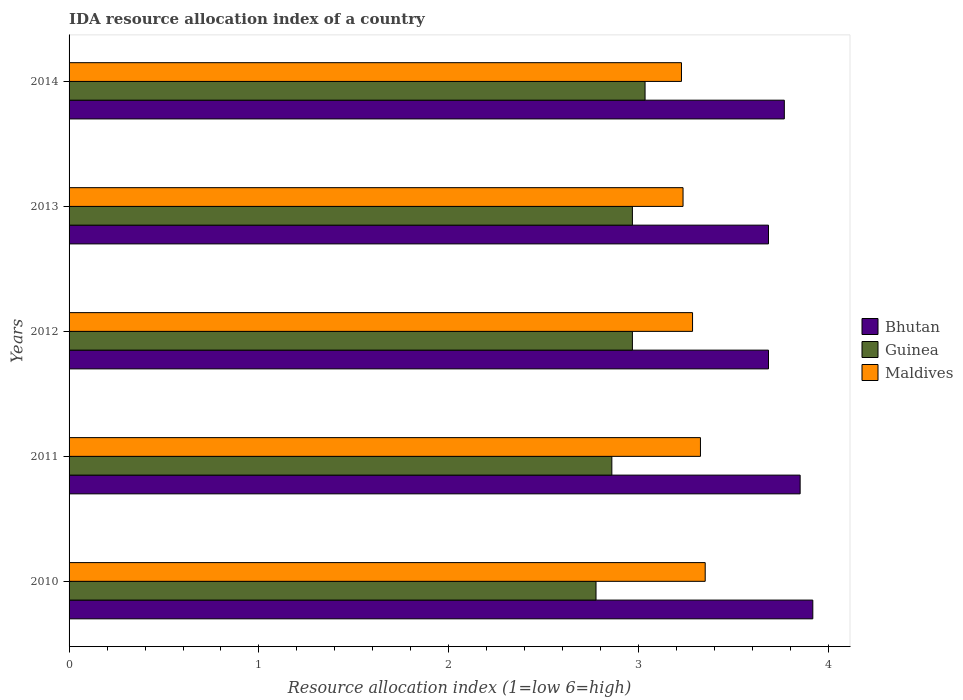Are the number of bars per tick equal to the number of legend labels?
Keep it short and to the point. Yes. Are the number of bars on each tick of the Y-axis equal?
Your answer should be compact. Yes. How many bars are there on the 1st tick from the bottom?
Give a very brief answer. 3. In how many cases, is the number of bars for a given year not equal to the number of legend labels?
Provide a short and direct response. 0. What is the IDA resource allocation index in Maldives in 2012?
Offer a terse response. 3.28. Across all years, what is the maximum IDA resource allocation index in Guinea?
Provide a succinct answer. 3.03. Across all years, what is the minimum IDA resource allocation index in Bhutan?
Keep it short and to the point. 3.68. In which year was the IDA resource allocation index in Guinea minimum?
Offer a very short reply. 2010. What is the total IDA resource allocation index in Maldives in the graph?
Provide a succinct answer. 16.42. What is the difference between the IDA resource allocation index in Bhutan in 2013 and that in 2014?
Your response must be concise. -0.08. What is the difference between the IDA resource allocation index in Guinea in 2010 and the IDA resource allocation index in Maldives in 2014?
Your answer should be very brief. -0.45. What is the average IDA resource allocation index in Guinea per year?
Offer a terse response. 2.92. In the year 2013, what is the difference between the IDA resource allocation index in Bhutan and IDA resource allocation index in Guinea?
Ensure brevity in your answer.  0.72. What is the ratio of the IDA resource allocation index in Maldives in 2010 to that in 2012?
Your response must be concise. 1.02. Is the IDA resource allocation index in Bhutan in 2010 less than that in 2013?
Keep it short and to the point. No. What is the difference between the highest and the second highest IDA resource allocation index in Maldives?
Give a very brief answer. 0.02. What is the difference between the highest and the lowest IDA resource allocation index in Bhutan?
Your answer should be very brief. 0.23. What does the 2nd bar from the top in 2014 represents?
Provide a succinct answer. Guinea. What does the 3rd bar from the bottom in 2011 represents?
Offer a very short reply. Maldives. Are all the bars in the graph horizontal?
Offer a very short reply. Yes. How many years are there in the graph?
Make the answer very short. 5. Are the values on the major ticks of X-axis written in scientific E-notation?
Make the answer very short. No. Does the graph contain any zero values?
Provide a succinct answer. No. How many legend labels are there?
Give a very brief answer. 3. How are the legend labels stacked?
Your answer should be compact. Vertical. What is the title of the graph?
Offer a terse response. IDA resource allocation index of a country. Does "Faeroe Islands" appear as one of the legend labels in the graph?
Your response must be concise. No. What is the label or title of the X-axis?
Your response must be concise. Resource allocation index (1=low 6=high). What is the Resource allocation index (1=low 6=high) of Bhutan in 2010?
Ensure brevity in your answer.  3.92. What is the Resource allocation index (1=low 6=high) in Guinea in 2010?
Offer a very short reply. 2.77. What is the Resource allocation index (1=low 6=high) of Maldives in 2010?
Offer a terse response. 3.35. What is the Resource allocation index (1=low 6=high) in Bhutan in 2011?
Give a very brief answer. 3.85. What is the Resource allocation index (1=low 6=high) of Guinea in 2011?
Offer a very short reply. 2.86. What is the Resource allocation index (1=low 6=high) of Maldives in 2011?
Make the answer very short. 3.33. What is the Resource allocation index (1=low 6=high) in Bhutan in 2012?
Offer a very short reply. 3.68. What is the Resource allocation index (1=low 6=high) in Guinea in 2012?
Your response must be concise. 2.97. What is the Resource allocation index (1=low 6=high) in Maldives in 2012?
Provide a succinct answer. 3.28. What is the Resource allocation index (1=low 6=high) of Bhutan in 2013?
Offer a terse response. 3.68. What is the Resource allocation index (1=low 6=high) in Guinea in 2013?
Provide a succinct answer. 2.97. What is the Resource allocation index (1=low 6=high) in Maldives in 2013?
Your response must be concise. 3.23. What is the Resource allocation index (1=low 6=high) of Bhutan in 2014?
Your response must be concise. 3.77. What is the Resource allocation index (1=low 6=high) in Guinea in 2014?
Your response must be concise. 3.03. What is the Resource allocation index (1=low 6=high) of Maldives in 2014?
Your answer should be compact. 3.23. Across all years, what is the maximum Resource allocation index (1=low 6=high) in Bhutan?
Keep it short and to the point. 3.92. Across all years, what is the maximum Resource allocation index (1=low 6=high) in Guinea?
Your response must be concise. 3.03. Across all years, what is the maximum Resource allocation index (1=low 6=high) of Maldives?
Keep it short and to the point. 3.35. Across all years, what is the minimum Resource allocation index (1=low 6=high) in Bhutan?
Offer a terse response. 3.68. Across all years, what is the minimum Resource allocation index (1=low 6=high) in Guinea?
Offer a very short reply. 2.77. Across all years, what is the minimum Resource allocation index (1=low 6=high) of Maldives?
Make the answer very short. 3.23. What is the total Resource allocation index (1=low 6=high) in Maldives in the graph?
Offer a very short reply. 16.42. What is the difference between the Resource allocation index (1=low 6=high) in Bhutan in 2010 and that in 2011?
Give a very brief answer. 0.07. What is the difference between the Resource allocation index (1=low 6=high) of Guinea in 2010 and that in 2011?
Make the answer very short. -0.08. What is the difference between the Resource allocation index (1=low 6=high) in Maldives in 2010 and that in 2011?
Your response must be concise. 0.03. What is the difference between the Resource allocation index (1=low 6=high) in Bhutan in 2010 and that in 2012?
Provide a short and direct response. 0.23. What is the difference between the Resource allocation index (1=low 6=high) in Guinea in 2010 and that in 2012?
Your response must be concise. -0.19. What is the difference between the Resource allocation index (1=low 6=high) in Maldives in 2010 and that in 2012?
Make the answer very short. 0.07. What is the difference between the Resource allocation index (1=low 6=high) in Bhutan in 2010 and that in 2013?
Offer a very short reply. 0.23. What is the difference between the Resource allocation index (1=low 6=high) in Guinea in 2010 and that in 2013?
Offer a terse response. -0.19. What is the difference between the Resource allocation index (1=low 6=high) of Maldives in 2010 and that in 2013?
Give a very brief answer. 0.12. What is the difference between the Resource allocation index (1=low 6=high) in Guinea in 2010 and that in 2014?
Give a very brief answer. -0.26. What is the difference between the Resource allocation index (1=low 6=high) of Maldives in 2010 and that in 2014?
Provide a short and direct response. 0.12. What is the difference between the Resource allocation index (1=low 6=high) in Guinea in 2011 and that in 2012?
Provide a short and direct response. -0.11. What is the difference between the Resource allocation index (1=low 6=high) in Maldives in 2011 and that in 2012?
Ensure brevity in your answer.  0.04. What is the difference between the Resource allocation index (1=low 6=high) in Bhutan in 2011 and that in 2013?
Keep it short and to the point. 0.17. What is the difference between the Resource allocation index (1=low 6=high) in Guinea in 2011 and that in 2013?
Keep it short and to the point. -0.11. What is the difference between the Resource allocation index (1=low 6=high) of Maldives in 2011 and that in 2013?
Offer a very short reply. 0.09. What is the difference between the Resource allocation index (1=low 6=high) in Bhutan in 2011 and that in 2014?
Offer a terse response. 0.08. What is the difference between the Resource allocation index (1=low 6=high) of Guinea in 2011 and that in 2014?
Your answer should be compact. -0.17. What is the difference between the Resource allocation index (1=low 6=high) in Guinea in 2012 and that in 2013?
Your response must be concise. 0. What is the difference between the Resource allocation index (1=low 6=high) of Bhutan in 2012 and that in 2014?
Provide a short and direct response. -0.08. What is the difference between the Resource allocation index (1=low 6=high) in Guinea in 2012 and that in 2014?
Keep it short and to the point. -0.07. What is the difference between the Resource allocation index (1=low 6=high) in Maldives in 2012 and that in 2014?
Give a very brief answer. 0.06. What is the difference between the Resource allocation index (1=low 6=high) in Bhutan in 2013 and that in 2014?
Offer a terse response. -0.08. What is the difference between the Resource allocation index (1=low 6=high) in Guinea in 2013 and that in 2014?
Provide a succinct answer. -0.07. What is the difference between the Resource allocation index (1=low 6=high) of Maldives in 2013 and that in 2014?
Keep it short and to the point. 0.01. What is the difference between the Resource allocation index (1=low 6=high) in Bhutan in 2010 and the Resource allocation index (1=low 6=high) in Guinea in 2011?
Provide a short and direct response. 1.06. What is the difference between the Resource allocation index (1=low 6=high) in Bhutan in 2010 and the Resource allocation index (1=low 6=high) in Maldives in 2011?
Provide a short and direct response. 0.59. What is the difference between the Resource allocation index (1=low 6=high) in Guinea in 2010 and the Resource allocation index (1=low 6=high) in Maldives in 2011?
Ensure brevity in your answer.  -0.55. What is the difference between the Resource allocation index (1=low 6=high) of Bhutan in 2010 and the Resource allocation index (1=low 6=high) of Guinea in 2012?
Offer a very short reply. 0.95. What is the difference between the Resource allocation index (1=low 6=high) of Bhutan in 2010 and the Resource allocation index (1=low 6=high) of Maldives in 2012?
Give a very brief answer. 0.63. What is the difference between the Resource allocation index (1=low 6=high) of Guinea in 2010 and the Resource allocation index (1=low 6=high) of Maldives in 2012?
Provide a succinct answer. -0.51. What is the difference between the Resource allocation index (1=low 6=high) of Bhutan in 2010 and the Resource allocation index (1=low 6=high) of Guinea in 2013?
Make the answer very short. 0.95. What is the difference between the Resource allocation index (1=low 6=high) in Bhutan in 2010 and the Resource allocation index (1=low 6=high) in Maldives in 2013?
Give a very brief answer. 0.68. What is the difference between the Resource allocation index (1=low 6=high) of Guinea in 2010 and the Resource allocation index (1=low 6=high) of Maldives in 2013?
Keep it short and to the point. -0.46. What is the difference between the Resource allocation index (1=low 6=high) in Bhutan in 2010 and the Resource allocation index (1=low 6=high) in Guinea in 2014?
Ensure brevity in your answer.  0.88. What is the difference between the Resource allocation index (1=low 6=high) in Bhutan in 2010 and the Resource allocation index (1=low 6=high) in Maldives in 2014?
Give a very brief answer. 0.69. What is the difference between the Resource allocation index (1=low 6=high) of Guinea in 2010 and the Resource allocation index (1=low 6=high) of Maldives in 2014?
Provide a succinct answer. -0.45. What is the difference between the Resource allocation index (1=low 6=high) of Bhutan in 2011 and the Resource allocation index (1=low 6=high) of Guinea in 2012?
Provide a short and direct response. 0.88. What is the difference between the Resource allocation index (1=low 6=high) in Bhutan in 2011 and the Resource allocation index (1=low 6=high) in Maldives in 2012?
Ensure brevity in your answer.  0.57. What is the difference between the Resource allocation index (1=low 6=high) of Guinea in 2011 and the Resource allocation index (1=low 6=high) of Maldives in 2012?
Provide a succinct answer. -0.42. What is the difference between the Resource allocation index (1=low 6=high) in Bhutan in 2011 and the Resource allocation index (1=low 6=high) in Guinea in 2013?
Ensure brevity in your answer.  0.88. What is the difference between the Resource allocation index (1=low 6=high) in Bhutan in 2011 and the Resource allocation index (1=low 6=high) in Maldives in 2013?
Offer a terse response. 0.62. What is the difference between the Resource allocation index (1=low 6=high) of Guinea in 2011 and the Resource allocation index (1=low 6=high) of Maldives in 2013?
Offer a very short reply. -0.38. What is the difference between the Resource allocation index (1=low 6=high) of Bhutan in 2011 and the Resource allocation index (1=low 6=high) of Guinea in 2014?
Offer a terse response. 0.82. What is the difference between the Resource allocation index (1=low 6=high) of Guinea in 2011 and the Resource allocation index (1=low 6=high) of Maldives in 2014?
Provide a short and direct response. -0.37. What is the difference between the Resource allocation index (1=low 6=high) in Bhutan in 2012 and the Resource allocation index (1=low 6=high) in Guinea in 2013?
Give a very brief answer. 0.72. What is the difference between the Resource allocation index (1=low 6=high) in Bhutan in 2012 and the Resource allocation index (1=low 6=high) in Maldives in 2013?
Offer a terse response. 0.45. What is the difference between the Resource allocation index (1=low 6=high) in Guinea in 2012 and the Resource allocation index (1=low 6=high) in Maldives in 2013?
Provide a succinct answer. -0.27. What is the difference between the Resource allocation index (1=low 6=high) of Bhutan in 2012 and the Resource allocation index (1=low 6=high) of Guinea in 2014?
Give a very brief answer. 0.65. What is the difference between the Resource allocation index (1=low 6=high) in Bhutan in 2012 and the Resource allocation index (1=low 6=high) in Maldives in 2014?
Offer a very short reply. 0.46. What is the difference between the Resource allocation index (1=low 6=high) in Guinea in 2012 and the Resource allocation index (1=low 6=high) in Maldives in 2014?
Ensure brevity in your answer.  -0.26. What is the difference between the Resource allocation index (1=low 6=high) in Bhutan in 2013 and the Resource allocation index (1=low 6=high) in Guinea in 2014?
Make the answer very short. 0.65. What is the difference between the Resource allocation index (1=low 6=high) of Bhutan in 2013 and the Resource allocation index (1=low 6=high) of Maldives in 2014?
Provide a short and direct response. 0.46. What is the difference between the Resource allocation index (1=low 6=high) of Guinea in 2013 and the Resource allocation index (1=low 6=high) of Maldives in 2014?
Make the answer very short. -0.26. What is the average Resource allocation index (1=low 6=high) of Bhutan per year?
Provide a short and direct response. 3.78. What is the average Resource allocation index (1=low 6=high) in Guinea per year?
Give a very brief answer. 2.92. What is the average Resource allocation index (1=low 6=high) of Maldives per year?
Your response must be concise. 3.28. In the year 2010, what is the difference between the Resource allocation index (1=low 6=high) of Bhutan and Resource allocation index (1=low 6=high) of Guinea?
Your answer should be compact. 1.14. In the year 2010, what is the difference between the Resource allocation index (1=low 6=high) of Bhutan and Resource allocation index (1=low 6=high) of Maldives?
Offer a very short reply. 0.57. In the year 2010, what is the difference between the Resource allocation index (1=low 6=high) in Guinea and Resource allocation index (1=low 6=high) in Maldives?
Keep it short and to the point. -0.57. In the year 2011, what is the difference between the Resource allocation index (1=low 6=high) in Bhutan and Resource allocation index (1=low 6=high) in Guinea?
Give a very brief answer. 0.99. In the year 2011, what is the difference between the Resource allocation index (1=low 6=high) of Bhutan and Resource allocation index (1=low 6=high) of Maldives?
Ensure brevity in your answer.  0.53. In the year 2011, what is the difference between the Resource allocation index (1=low 6=high) in Guinea and Resource allocation index (1=low 6=high) in Maldives?
Offer a terse response. -0.47. In the year 2012, what is the difference between the Resource allocation index (1=low 6=high) of Bhutan and Resource allocation index (1=low 6=high) of Guinea?
Give a very brief answer. 0.72. In the year 2012, what is the difference between the Resource allocation index (1=low 6=high) of Guinea and Resource allocation index (1=low 6=high) of Maldives?
Offer a terse response. -0.32. In the year 2013, what is the difference between the Resource allocation index (1=low 6=high) of Bhutan and Resource allocation index (1=low 6=high) of Guinea?
Provide a short and direct response. 0.72. In the year 2013, what is the difference between the Resource allocation index (1=low 6=high) in Bhutan and Resource allocation index (1=low 6=high) in Maldives?
Give a very brief answer. 0.45. In the year 2013, what is the difference between the Resource allocation index (1=low 6=high) in Guinea and Resource allocation index (1=low 6=high) in Maldives?
Keep it short and to the point. -0.27. In the year 2014, what is the difference between the Resource allocation index (1=low 6=high) in Bhutan and Resource allocation index (1=low 6=high) in Guinea?
Your answer should be very brief. 0.73. In the year 2014, what is the difference between the Resource allocation index (1=low 6=high) of Bhutan and Resource allocation index (1=low 6=high) of Maldives?
Make the answer very short. 0.54. In the year 2014, what is the difference between the Resource allocation index (1=low 6=high) in Guinea and Resource allocation index (1=low 6=high) in Maldives?
Keep it short and to the point. -0.19. What is the ratio of the Resource allocation index (1=low 6=high) in Bhutan in 2010 to that in 2011?
Provide a succinct answer. 1.02. What is the ratio of the Resource allocation index (1=low 6=high) of Guinea in 2010 to that in 2011?
Give a very brief answer. 0.97. What is the ratio of the Resource allocation index (1=low 6=high) of Maldives in 2010 to that in 2011?
Give a very brief answer. 1.01. What is the ratio of the Resource allocation index (1=low 6=high) of Bhutan in 2010 to that in 2012?
Your response must be concise. 1.06. What is the ratio of the Resource allocation index (1=low 6=high) of Guinea in 2010 to that in 2012?
Provide a succinct answer. 0.94. What is the ratio of the Resource allocation index (1=low 6=high) of Maldives in 2010 to that in 2012?
Offer a very short reply. 1.02. What is the ratio of the Resource allocation index (1=low 6=high) of Bhutan in 2010 to that in 2013?
Keep it short and to the point. 1.06. What is the ratio of the Resource allocation index (1=low 6=high) in Guinea in 2010 to that in 2013?
Make the answer very short. 0.94. What is the ratio of the Resource allocation index (1=low 6=high) in Maldives in 2010 to that in 2013?
Offer a very short reply. 1.04. What is the ratio of the Resource allocation index (1=low 6=high) in Bhutan in 2010 to that in 2014?
Offer a terse response. 1.04. What is the ratio of the Resource allocation index (1=low 6=high) of Guinea in 2010 to that in 2014?
Your answer should be compact. 0.91. What is the ratio of the Resource allocation index (1=low 6=high) of Maldives in 2010 to that in 2014?
Give a very brief answer. 1.04. What is the ratio of the Resource allocation index (1=low 6=high) of Bhutan in 2011 to that in 2012?
Provide a succinct answer. 1.05. What is the ratio of the Resource allocation index (1=low 6=high) of Guinea in 2011 to that in 2012?
Provide a short and direct response. 0.96. What is the ratio of the Resource allocation index (1=low 6=high) of Maldives in 2011 to that in 2012?
Provide a succinct answer. 1.01. What is the ratio of the Resource allocation index (1=low 6=high) of Bhutan in 2011 to that in 2013?
Provide a succinct answer. 1.05. What is the ratio of the Resource allocation index (1=low 6=high) in Guinea in 2011 to that in 2013?
Provide a short and direct response. 0.96. What is the ratio of the Resource allocation index (1=low 6=high) in Maldives in 2011 to that in 2013?
Keep it short and to the point. 1.03. What is the ratio of the Resource allocation index (1=low 6=high) in Bhutan in 2011 to that in 2014?
Keep it short and to the point. 1.02. What is the ratio of the Resource allocation index (1=low 6=high) of Guinea in 2011 to that in 2014?
Make the answer very short. 0.94. What is the ratio of the Resource allocation index (1=low 6=high) in Maldives in 2011 to that in 2014?
Your answer should be very brief. 1.03. What is the ratio of the Resource allocation index (1=low 6=high) of Maldives in 2012 to that in 2013?
Ensure brevity in your answer.  1.02. What is the ratio of the Resource allocation index (1=low 6=high) of Bhutan in 2012 to that in 2014?
Give a very brief answer. 0.98. What is the ratio of the Resource allocation index (1=low 6=high) in Guinea in 2012 to that in 2014?
Provide a succinct answer. 0.98. What is the ratio of the Resource allocation index (1=low 6=high) in Maldives in 2012 to that in 2014?
Provide a short and direct response. 1.02. What is the ratio of the Resource allocation index (1=low 6=high) in Bhutan in 2013 to that in 2014?
Ensure brevity in your answer.  0.98. What is the ratio of the Resource allocation index (1=low 6=high) of Maldives in 2013 to that in 2014?
Provide a succinct answer. 1. What is the difference between the highest and the second highest Resource allocation index (1=low 6=high) in Bhutan?
Give a very brief answer. 0.07. What is the difference between the highest and the second highest Resource allocation index (1=low 6=high) in Guinea?
Your answer should be compact. 0.07. What is the difference between the highest and the second highest Resource allocation index (1=low 6=high) of Maldives?
Your response must be concise. 0.03. What is the difference between the highest and the lowest Resource allocation index (1=low 6=high) in Bhutan?
Offer a terse response. 0.23. What is the difference between the highest and the lowest Resource allocation index (1=low 6=high) in Guinea?
Provide a succinct answer. 0.26. What is the difference between the highest and the lowest Resource allocation index (1=low 6=high) in Maldives?
Make the answer very short. 0.12. 